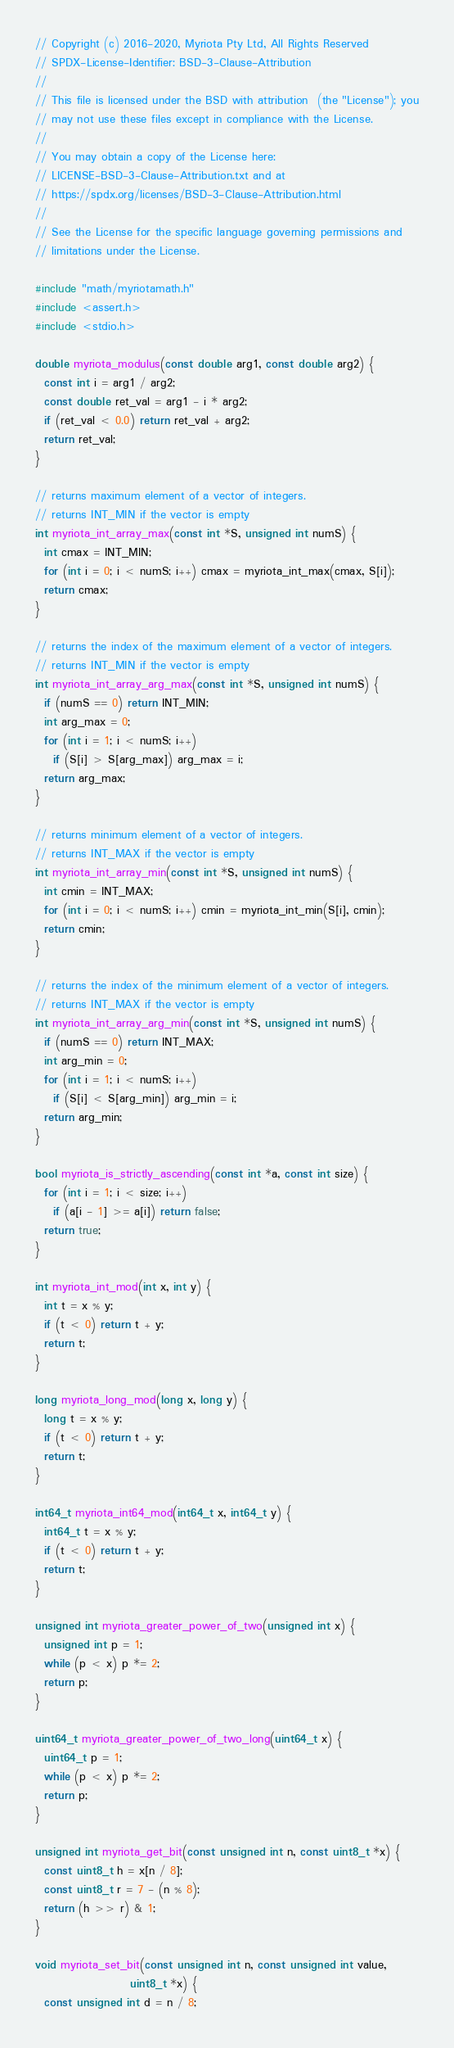Convert code to text. <code><loc_0><loc_0><loc_500><loc_500><_C_>// Copyright (c) 2016-2020, Myriota Pty Ltd, All Rights Reserved
// SPDX-License-Identifier: BSD-3-Clause-Attribution
//
// This file is licensed under the BSD with attribution  (the "License"); you
// may not use these files except in compliance with the License.
//
// You may obtain a copy of the License here:
// LICENSE-BSD-3-Clause-Attribution.txt and at
// https://spdx.org/licenses/BSD-3-Clause-Attribution.html
//
// See the License for the specific language governing permissions and
// limitations under the License.

#include "math/myriotamath.h"
#include <assert.h>
#include <stdio.h>

double myriota_modulus(const double arg1, const double arg2) {
  const int i = arg1 / arg2;
  const double ret_val = arg1 - i * arg2;
  if (ret_val < 0.0) return ret_val + arg2;
  return ret_val;
}

// returns maximum element of a vector of integers.
// returns INT_MIN if the vector is empty
int myriota_int_array_max(const int *S, unsigned int numS) {
  int cmax = INT_MIN;
  for (int i = 0; i < numS; i++) cmax = myriota_int_max(cmax, S[i]);
  return cmax;
}

// returns the index of the maximum element of a vector of integers.
// returns INT_MIN if the vector is empty
int myriota_int_array_arg_max(const int *S, unsigned int numS) {
  if (numS == 0) return INT_MIN;
  int arg_max = 0;
  for (int i = 1; i < numS; i++)
    if (S[i] > S[arg_max]) arg_max = i;
  return arg_max;
}

// returns minimum element of a vector of integers.
// returns INT_MAX if the vector is empty
int myriota_int_array_min(const int *S, unsigned int numS) {
  int cmin = INT_MAX;
  for (int i = 0; i < numS; i++) cmin = myriota_int_min(S[i], cmin);
  return cmin;
}

// returns the index of the minimum element of a vector of integers.
// returns INT_MAX if the vector is empty
int myriota_int_array_arg_min(const int *S, unsigned int numS) {
  if (numS == 0) return INT_MAX;
  int arg_min = 0;
  for (int i = 1; i < numS; i++)
    if (S[i] < S[arg_min]) arg_min = i;
  return arg_min;
}

bool myriota_is_strictly_ascending(const int *a, const int size) {
  for (int i = 1; i < size; i++)
    if (a[i - 1] >= a[i]) return false;
  return true;
}

int myriota_int_mod(int x, int y) {
  int t = x % y;
  if (t < 0) return t + y;
  return t;
}

long myriota_long_mod(long x, long y) {
  long t = x % y;
  if (t < 0) return t + y;
  return t;
}

int64_t myriota_int64_mod(int64_t x, int64_t y) {
  int64_t t = x % y;
  if (t < 0) return t + y;
  return t;
}

unsigned int myriota_greater_power_of_two(unsigned int x) {
  unsigned int p = 1;
  while (p < x) p *= 2;
  return p;
}

uint64_t myriota_greater_power_of_two_long(uint64_t x) {
  uint64_t p = 1;
  while (p < x) p *= 2;
  return p;
}

unsigned int myriota_get_bit(const unsigned int n, const uint8_t *x) {
  const uint8_t h = x[n / 8];
  const uint8_t r = 7 - (n % 8);
  return (h >> r) & 1;
}

void myriota_set_bit(const unsigned int n, const unsigned int value,
                     uint8_t *x) {
  const unsigned int d = n / 8;</code> 